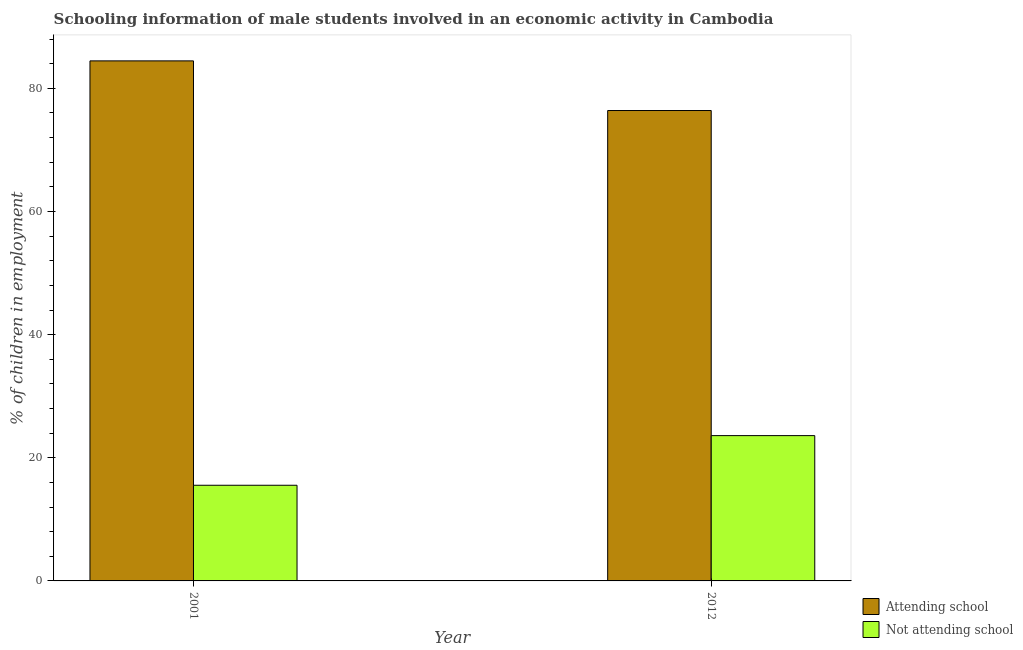How many groups of bars are there?
Give a very brief answer. 2. Are the number of bars on each tick of the X-axis equal?
Offer a terse response. Yes. How many bars are there on the 1st tick from the left?
Make the answer very short. 2. What is the label of the 2nd group of bars from the left?
Ensure brevity in your answer.  2012. In how many cases, is the number of bars for a given year not equal to the number of legend labels?
Give a very brief answer. 0. What is the percentage of employed males who are attending school in 2012?
Ensure brevity in your answer.  76.4. Across all years, what is the maximum percentage of employed males who are attending school?
Provide a short and direct response. 84.46. Across all years, what is the minimum percentage of employed males who are attending school?
Ensure brevity in your answer.  76.4. What is the total percentage of employed males who are attending school in the graph?
Ensure brevity in your answer.  160.86. What is the difference between the percentage of employed males who are not attending school in 2001 and that in 2012?
Provide a succinct answer. -8.06. What is the difference between the percentage of employed males who are attending school in 2001 and the percentage of employed males who are not attending school in 2012?
Offer a terse response. 8.06. What is the average percentage of employed males who are not attending school per year?
Ensure brevity in your answer.  19.57. In the year 2001, what is the difference between the percentage of employed males who are not attending school and percentage of employed males who are attending school?
Provide a short and direct response. 0. What is the ratio of the percentage of employed males who are attending school in 2001 to that in 2012?
Ensure brevity in your answer.  1.11. Is the percentage of employed males who are attending school in 2001 less than that in 2012?
Provide a short and direct response. No. What does the 1st bar from the left in 2012 represents?
Keep it short and to the point. Attending school. What does the 1st bar from the right in 2012 represents?
Offer a very short reply. Not attending school. How many bars are there?
Provide a succinct answer. 4. Are all the bars in the graph horizontal?
Offer a very short reply. No. How many years are there in the graph?
Your response must be concise. 2. What is the difference between two consecutive major ticks on the Y-axis?
Your answer should be very brief. 20. How many legend labels are there?
Your response must be concise. 2. What is the title of the graph?
Offer a terse response. Schooling information of male students involved in an economic activity in Cambodia. Does "National Visitors" appear as one of the legend labels in the graph?
Provide a short and direct response. No. What is the label or title of the X-axis?
Provide a short and direct response. Year. What is the label or title of the Y-axis?
Offer a very short reply. % of children in employment. What is the % of children in employment of Attending school in 2001?
Provide a short and direct response. 84.46. What is the % of children in employment of Not attending school in 2001?
Make the answer very short. 15.54. What is the % of children in employment of Attending school in 2012?
Make the answer very short. 76.4. What is the % of children in employment of Not attending school in 2012?
Your response must be concise. 23.6. Across all years, what is the maximum % of children in employment of Attending school?
Give a very brief answer. 84.46. Across all years, what is the maximum % of children in employment in Not attending school?
Offer a very short reply. 23.6. Across all years, what is the minimum % of children in employment in Attending school?
Your response must be concise. 76.4. Across all years, what is the minimum % of children in employment of Not attending school?
Keep it short and to the point. 15.54. What is the total % of children in employment of Attending school in the graph?
Provide a succinct answer. 160.86. What is the total % of children in employment of Not attending school in the graph?
Offer a terse response. 39.14. What is the difference between the % of children in employment of Attending school in 2001 and that in 2012?
Your response must be concise. 8.06. What is the difference between the % of children in employment in Not attending school in 2001 and that in 2012?
Offer a terse response. -8.06. What is the difference between the % of children in employment of Attending school in 2001 and the % of children in employment of Not attending school in 2012?
Give a very brief answer. 60.86. What is the average % of children in employment of Attending school per year?
Offer a very short reply. 80.43. What is the average % of children in employment of Not attending school per year?
Offer a very short reply. 19.57. In the year 2001, what is the difference between the % of children in employment in Attending school and % of children in employment in Not attending school?
Provide a succinct answer. 68.93. In the year 2012, what is the difference between the % of children in employment of Attending school and % of children in employment of Not attending school?
Ensure brevity in your answer.  52.8. What is the ratio of the % of children in employment of Attending school in 2001 to that in 2012?
Give a very brief answer. 1.11. What is the ratio of the % of children in employment of Not attending school in 2001 to that in 2012?
Provide a short and direct response. 0.66. What is the difference between the highest and the second highest % of children in employment of Attending school?
Give a very brief answer. 8.06. What is the difference between the highest and the second highest % of children in employment of Not attending school?
Provide a short and direct response. 8.06. What is the difference between the highest and the lowest % of children in employment of Attending school?
Offer a very short reply. 8.06. What is the difference between the highest and the lowest % of children in employment in Not attending school?
Offer a terse response. 8.06. 